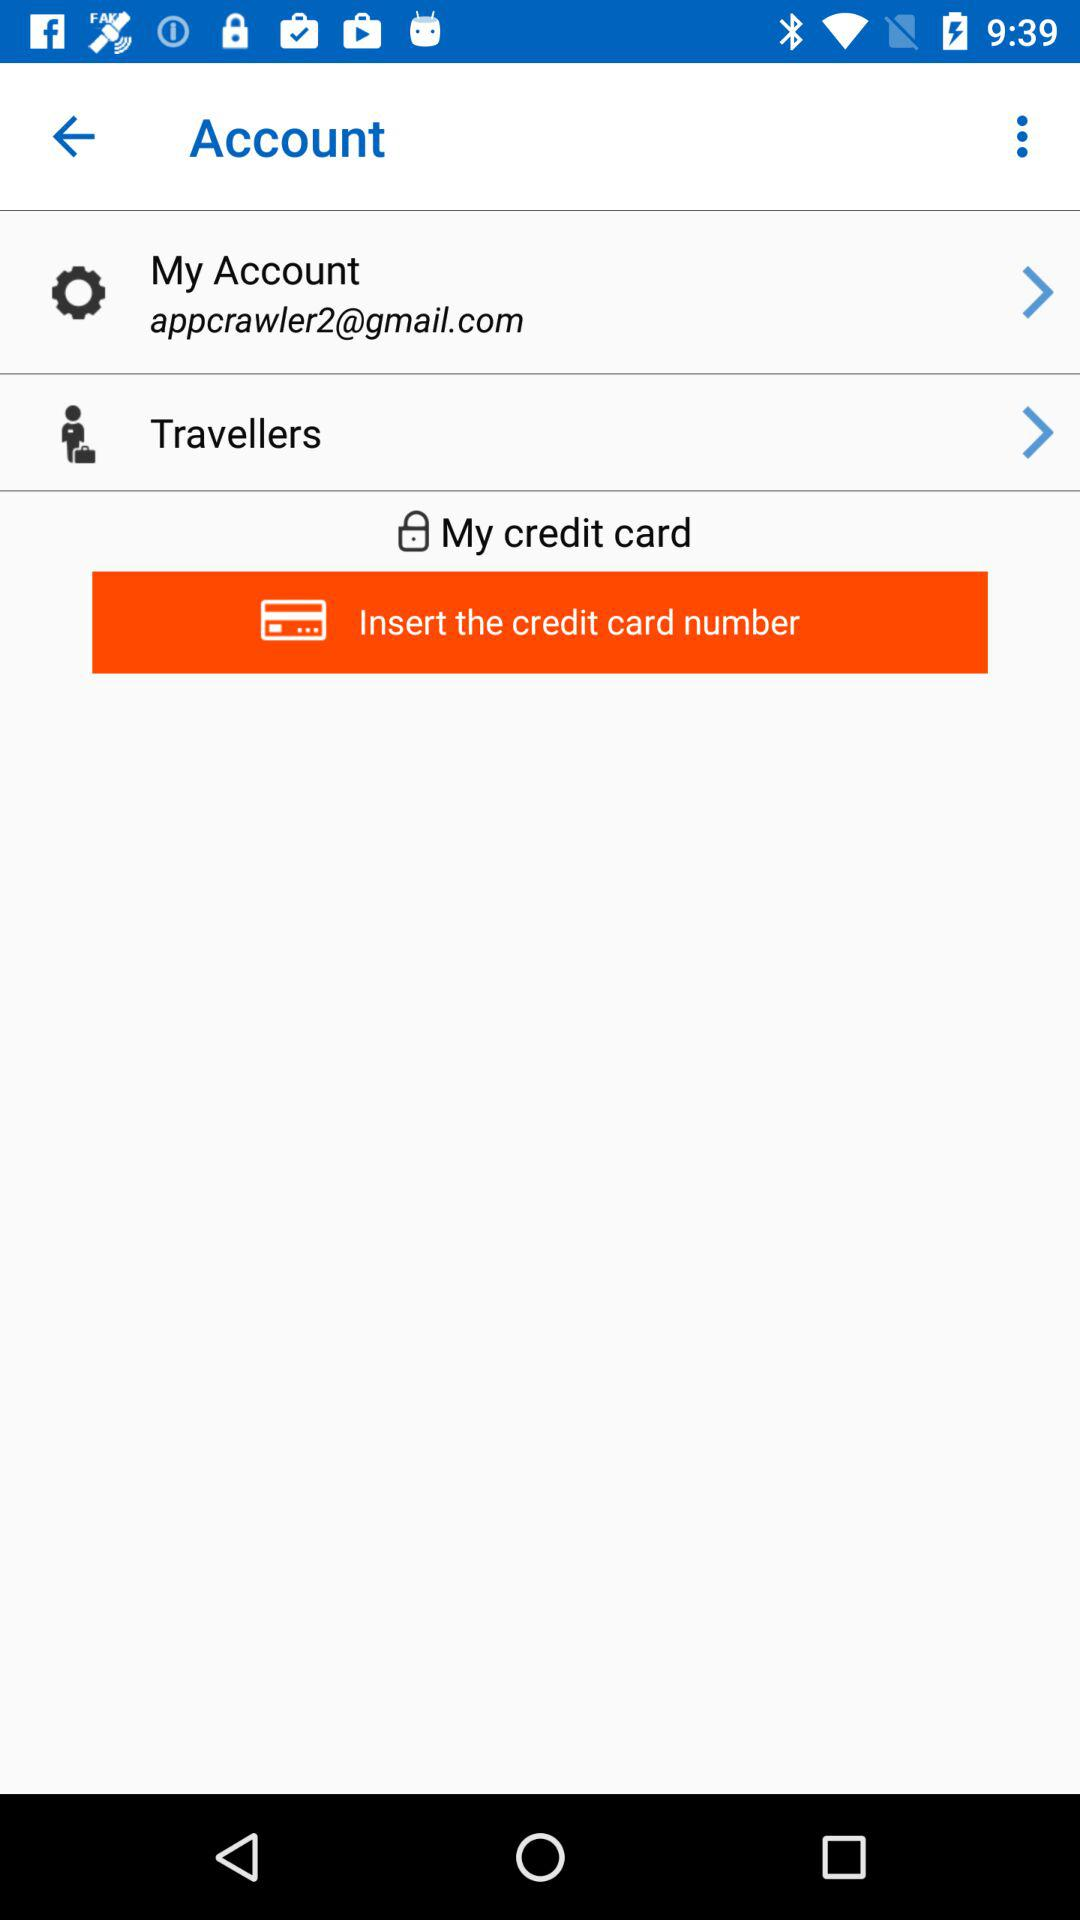What is the email address? The email address is appcrawler2@gmail.com. 